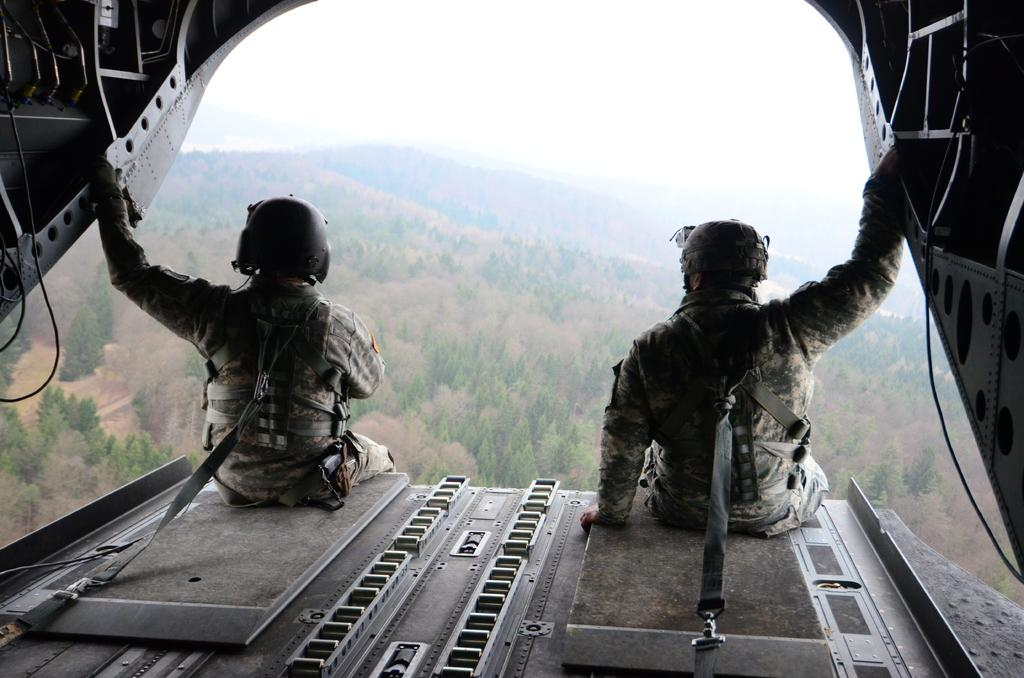How many people are sitting in the image? There are two persons sitting in the image. What are the persons wearing? The persons are wearing uniforms and helmets. What can be seen in the background of the image? There are trees visible in the background of the image. Are there any horses visible in the image? No, there are no horses present in the image. Is there a line of people waiting in the image? The image does not show a line of people; it only features two persons sitting. 